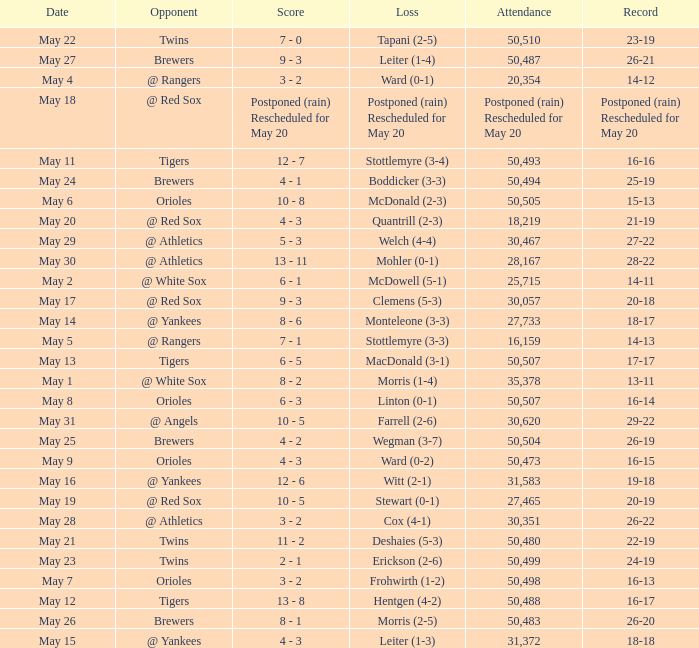What team did they lose to when they had a 28-22 record? Mohler (0-1). 